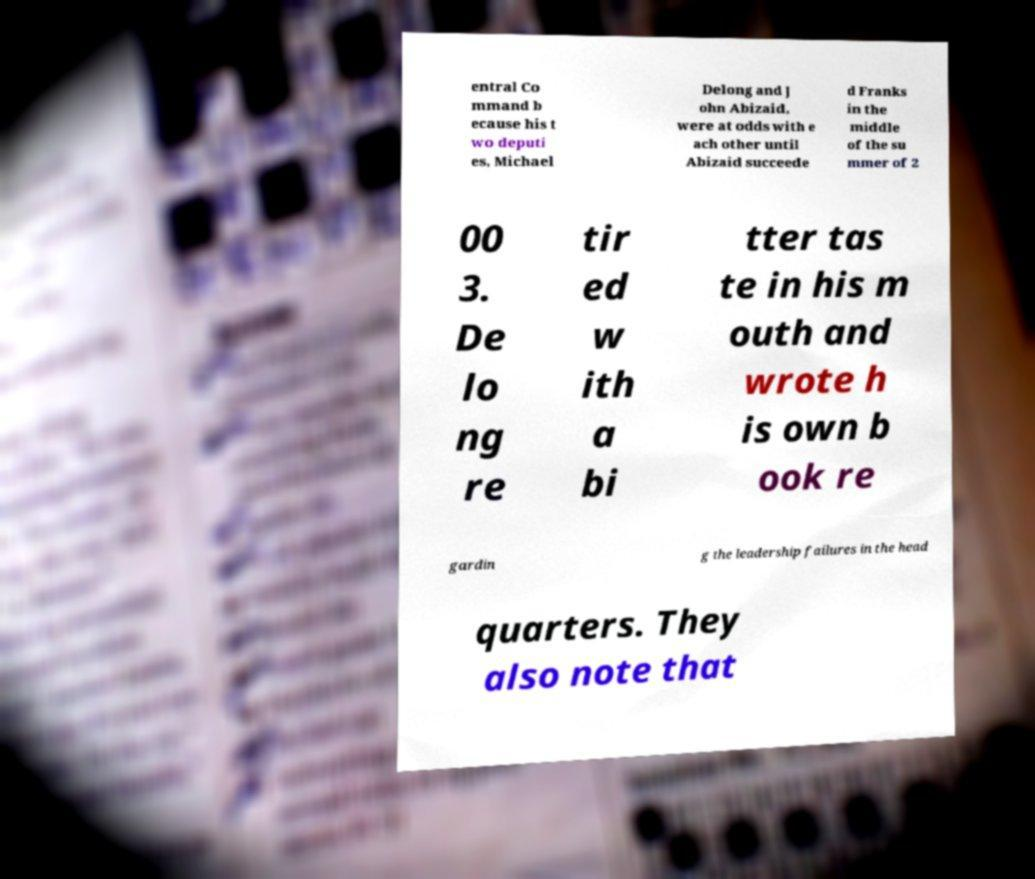I need the written content from this picture converted into text. Can you do that? entral Co mmand b ecause his t wo deputi es, Michael Delong and J ohn Abizaid, were at odds with e ach other until Abizaid succeede d Franks in the middle of the su mmer of 2 00 3. De lo ng re tir ed w ith a bi tter tas te in his m outh and wrote h is own b ook re gardin g the leadership failures in the head quarters. They also note that 